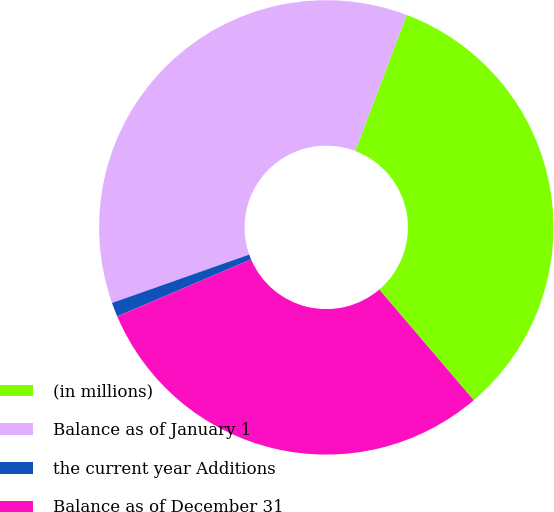Convert chart to OTSL. <chart><loc_0><loc_0><loc_500><loc_500><pie_chart><fcel>(in millions)<fcel>Balance as of January 1<fcel>the current year Additions<fcel>Balance as of December 31<nl><fcel>33.0%<fcel>36.16%<fcel>1.01%<fcel>29.84%<nl></chart> 